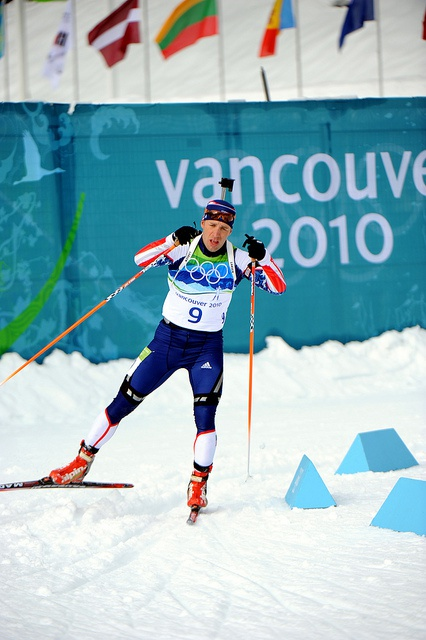Describe the objects in this image and their specific colors. I can see people in black, white, navy, and teal tones and skis in black, darkgray, gray, and maroon tones in this image. 